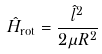<formula> <loc_0><loc_0><loc_500><loc_500>\hat { H } _ { \text {rot} } = \frac { \hat { l } ^ { 2 } } { 2 \mu R ^ { 2 } }</formula> 